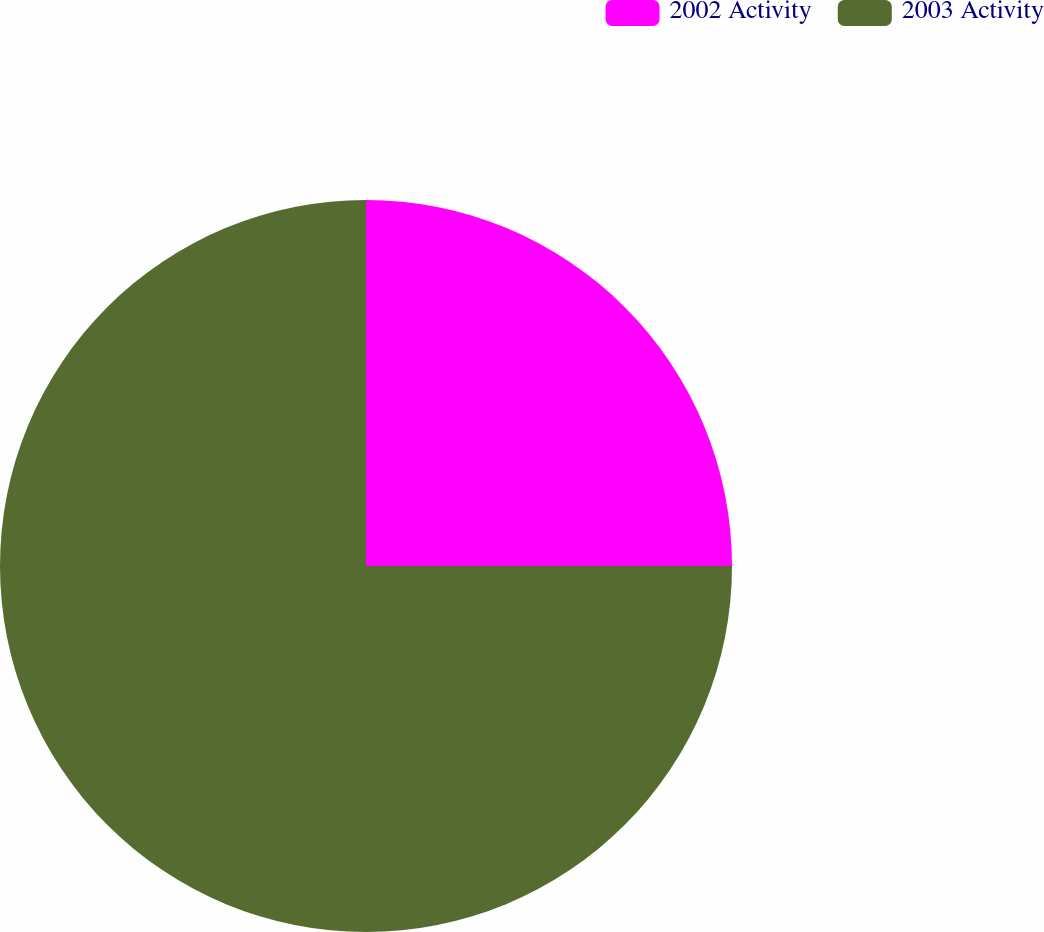Convert chart to OTSL. <chart><loc_0><loc_0><loc_500><loc_500><pie_chart><fcel>2002 Activity<fcel>2003 Activity<nl><fcel>25.0%<fcel>75.0%<nl></chart> 